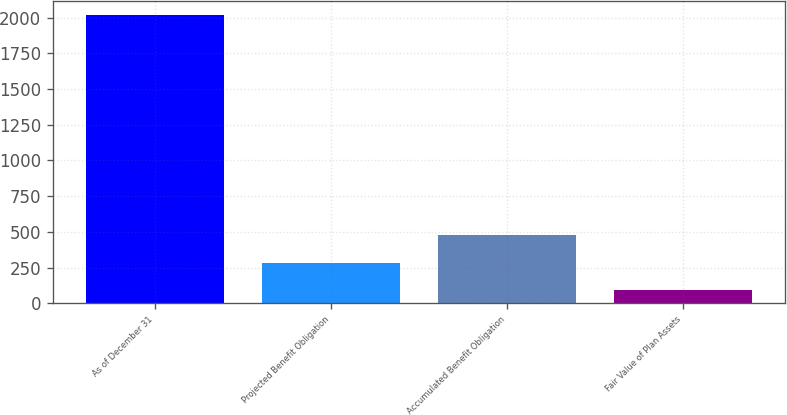Convert chart. <chart><loc_0><loc_0><loc_500><loc_500><bar_chart><fcel>As of December 31<fcel>Projected Benefit Obligation<fcel>Accumulated Benefit Obligation<fcel>Fair Value of Plan Assets<nl><fcel>2017<fcel>283.6<fcel>476.2<fcel>91<nl></chart> 